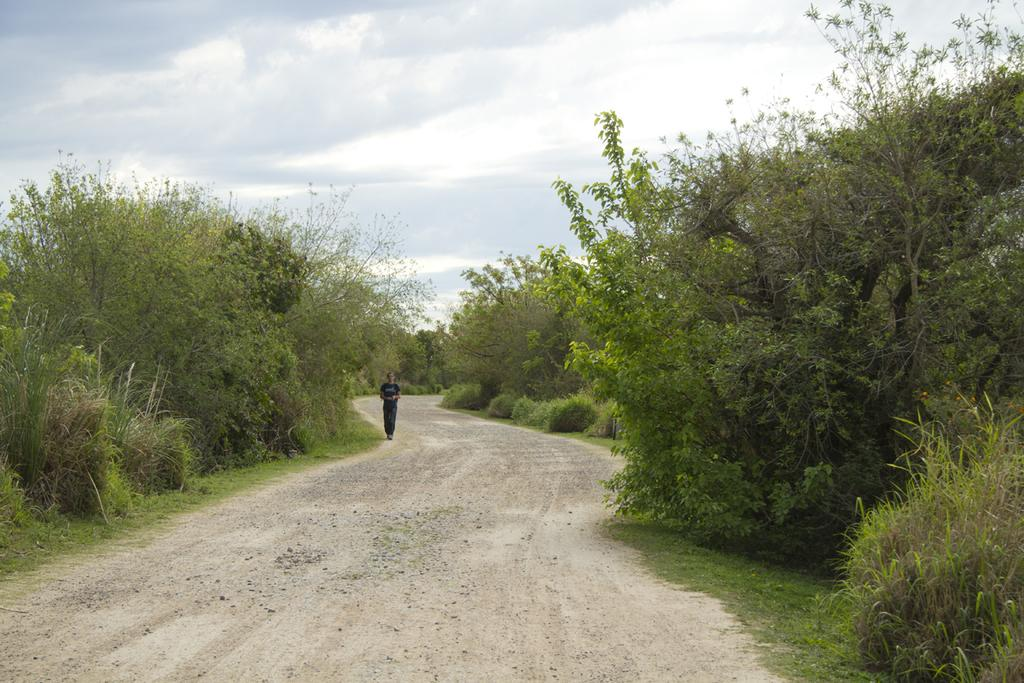What is the person in the image doing? The person is walking in the image. Where is the person walking? The person is walking on a path. What can be seen on both sides of the path? There are trees on the left side and the right side of the image. What is visible in the background of the image? The sky is visible in the background of the image. What type of division can be seen between the trees in the image? There is no division between the trees in the image; they are simply on both sides of the path. 